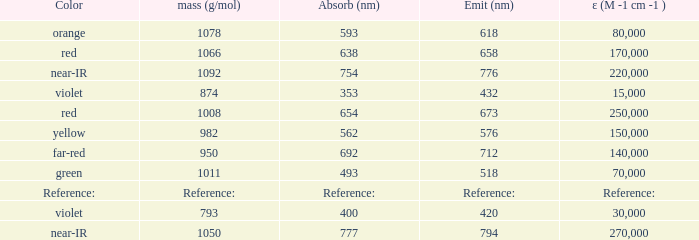Which Emission (in nanometers) has an absorbtion of 593 nm? 618.0. 